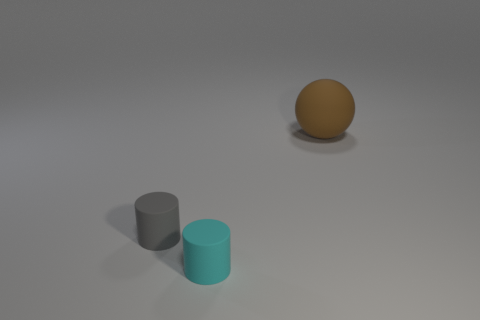What time of day or lighting situation does this scene represent? This scene appears to be an indoor setup with artificial lighting. The soft shadows and lack of natural light effects such as sunbeams suggest that the lighting is likely coming from overhead fixtures within a studio or controlled environment. 